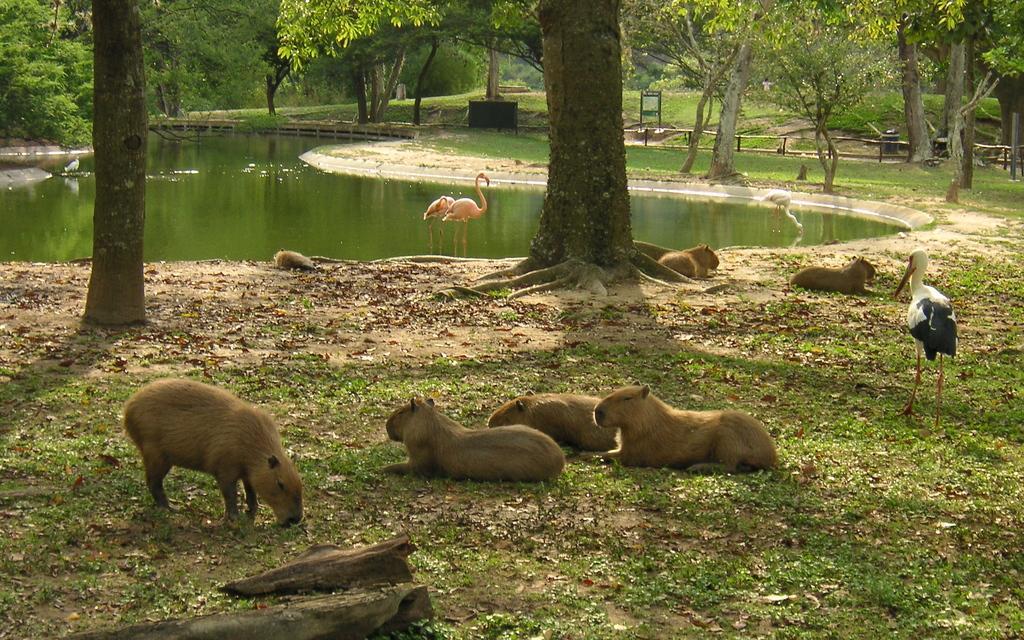How would you summarize this image in a sentence or two? In this picture we can see many small bears were sitting on the ground. On the right there is a white duck. In the water we can see two pink color ducks. In the background we can see many trees, plants and grass. On the top right corner we can see wooden fencing. 